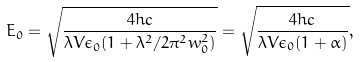Convert formula to latex. <formula><loc_0><loc_0><loc_500><loc_500>E _ { 0 } = \sqrt { \frac { 4 h c } { \lambda V \epsilon _ { 0 } ( 1 + \lambda ^ { 2 } / 2 \pi ^ { 2 } w _ { 0 } ^ { 2 } ) } } = \sqrt { \frac { 4 h c } { \lambda V \epsilon _ { 0 } ( 1 + \alpha ) } } ,</formula> 